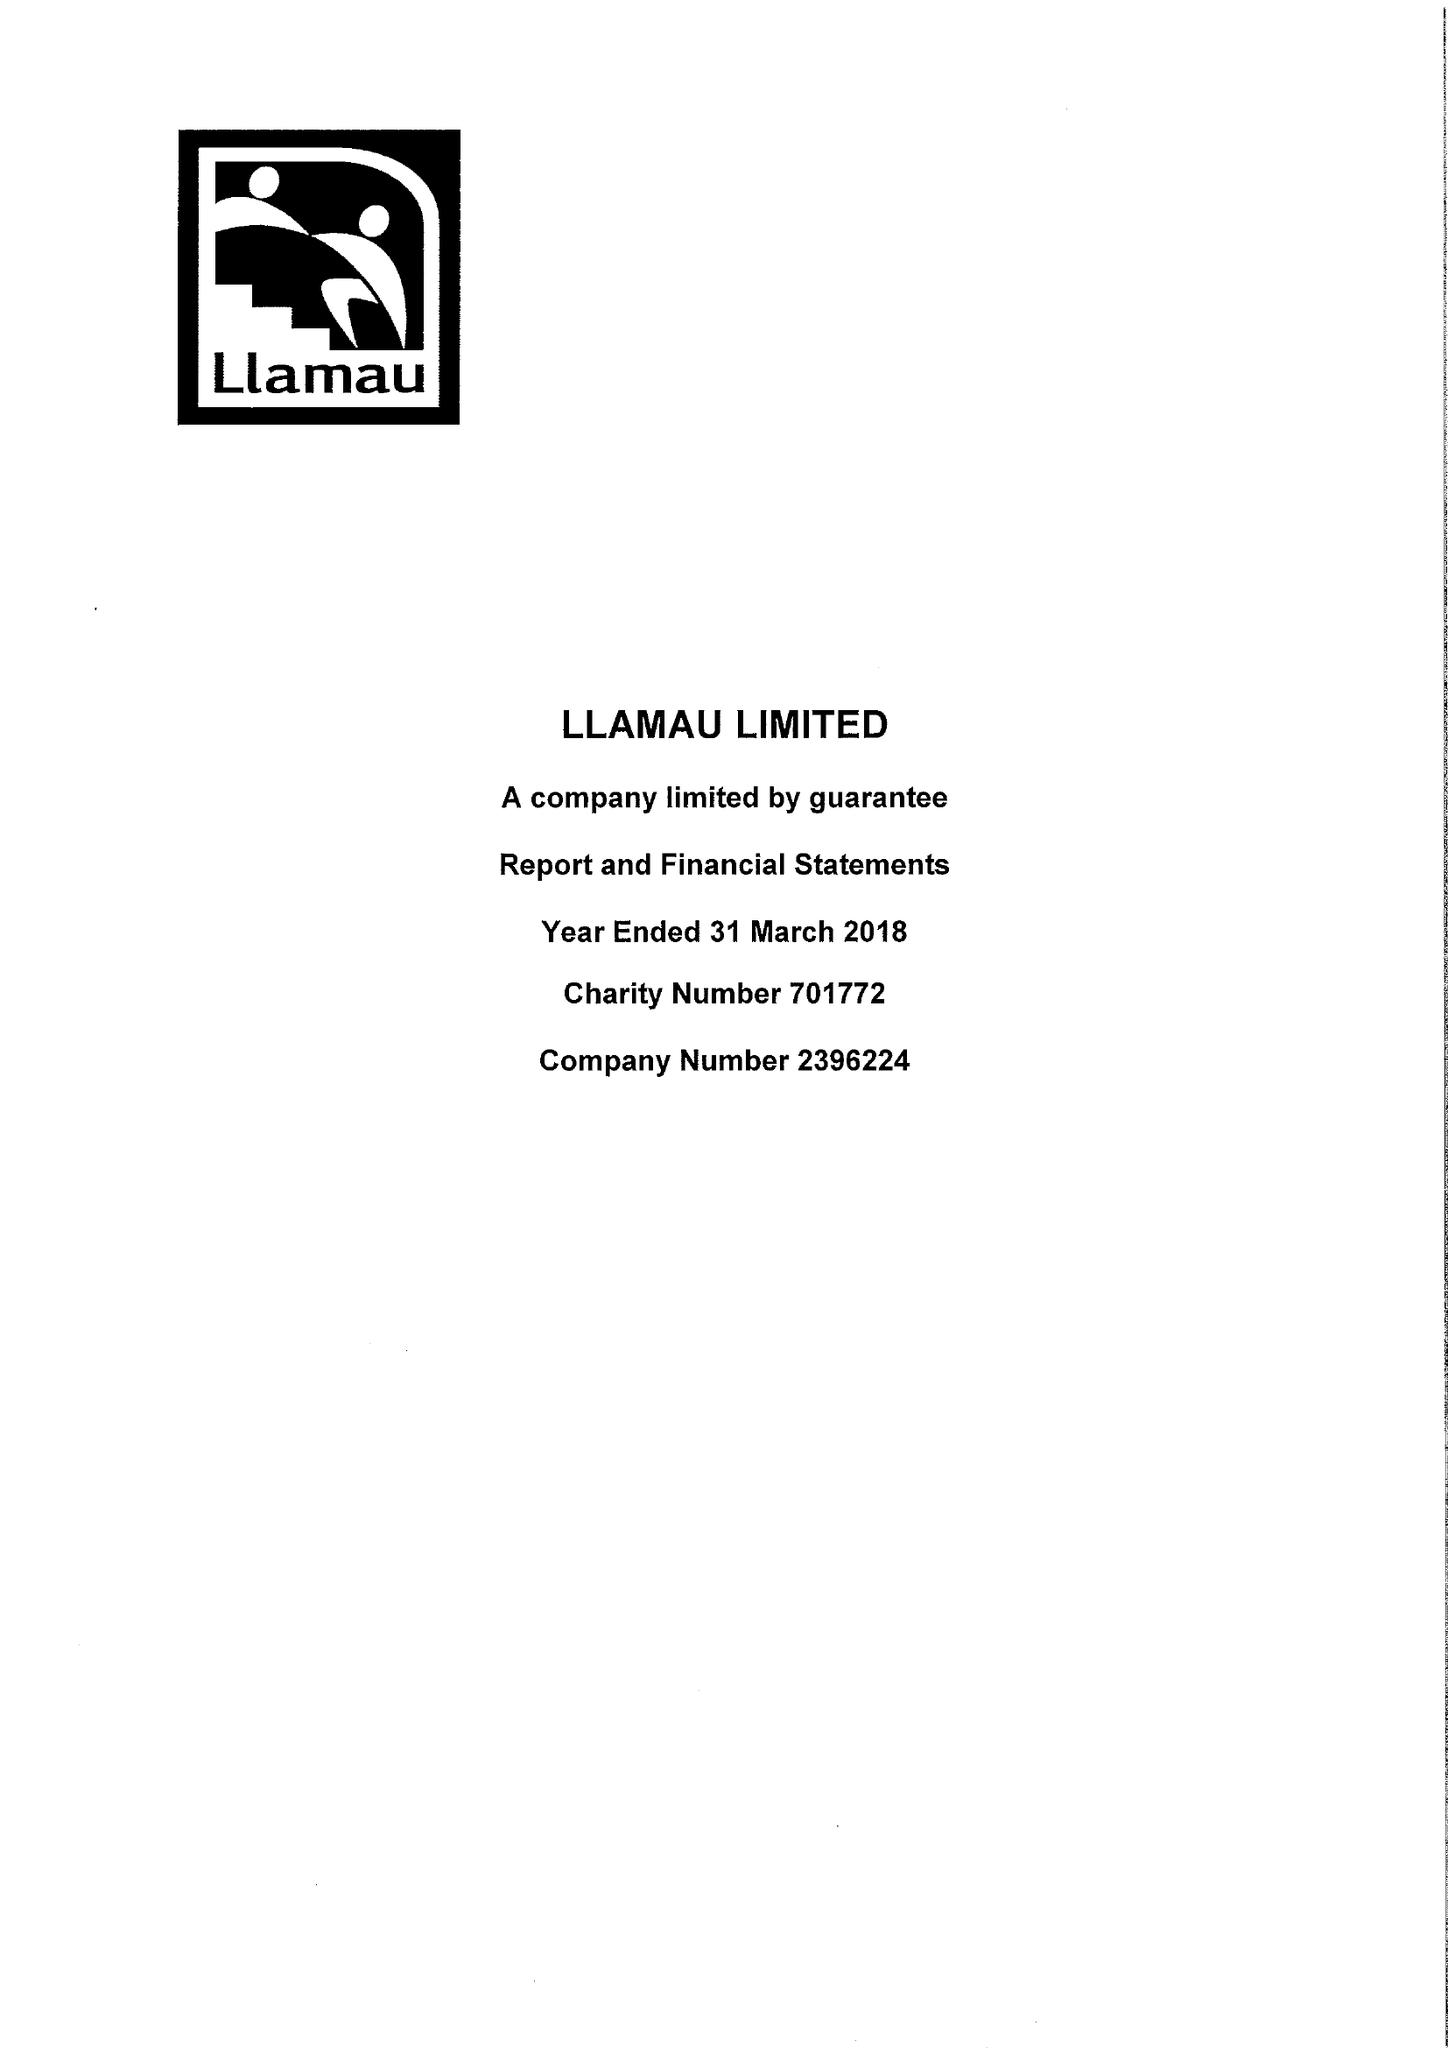What is the value for the report_date?
Answer the question using a single word or phrase. 2018-03-31 